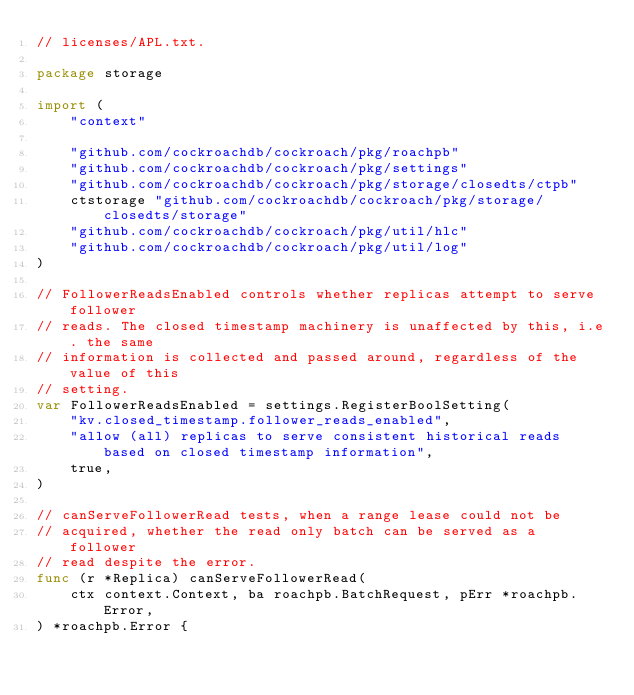Convert code to text. <code><loc_0><loc_0><loc_500><loc_500><_Go_>// licenses/APL.txt.

package storage

import (
	"context"

	"github.com/cockroachdb/cockroach/pkg/roachpb"
	"github.com/cockroachdb/cockroach/pkg/settings"
	"github.com/cockroachdb/cockroach/pkg/storage/closedts/ctpb"
	ctstorage "github.com/cockroachdb/cockroach/pkg/storage/closedts/storage"
	"github.com/cockroachdb/cockroach/pkg/util/hlc"
	"github.com/cockroachdb/cockroach/pkg/util/log"
)

// FollowerReadsEnabled controls whether replicas attempt to serve follower
// reads. The closed timestamp machinery is unaffected by this, i.e. the same
// information is collected and passed around, regardless of the value of this
// setting.
var FollowerReadsEnabled = settings.RegisterBoolSetting(
	"kv.closed_timestamp.follower_reads_enabled",
	"allow (all) replicas to serve consistent historical reads based on closed timestamp information",
	true,
)

// canServeFollowerRead tests, when a range lease could not be
// acquired, whether the read only batch can be served as a follower
// read despite the error.
func (r *Replica) canServeFollowerRead(
	ctx context.Context, ba roachpb.BatchRequest, pErr *roachpb.Error,
) *roachpb.Error {</code> 